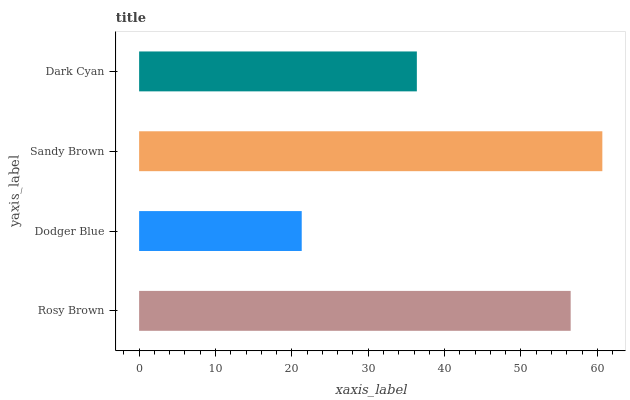Is Dodger Blue the minimum?
Answer yes or no. Yes. Is Sandy Brown the maximum?
Answer yes or no. Yes. Is Sandy Brown the minimum?
Answer yes or no. No. Is Dodger Blue the maximum?
Answer yes or no. No. Is Sandy Brown greater than Dodger Blue?
Answer yes or no. Yes. Is Dodger Blue less than Sandy Brown?
Answer yes or no. Yes. Is Dodger Blue greater than Sandy Brown?
Answer yes or no. No. Is Sandy Brown less than Dodger Blue?
Answer yes or no. No. Is Rosy Brown the high median?
Answer yes or no. Yes. Is Dark Cyan the low median?
Answer yes or no. Yes. Is Sandy Brown the high median?
Answer yes or no. No. Is Rosy Brown the low median?
Answer yes or no. No. 